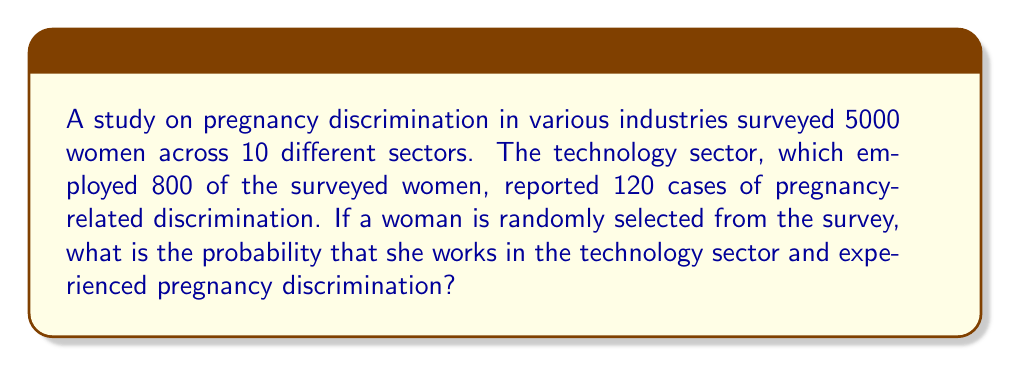Can you answer this question? Let's approach this step-by-step:

1) First, we need to calculate two probabilities:
   a) The probability of working in the technology sector
   b) The probability of experiencing pregnancy discrimination within the technology sector

2) Probability of working in the technology sector:
   $$P(\text{Tech}) = \frac{\text{Women in tech}}{\text{Total women}} = \frac{800}{5000} = 0.16$$

3) Probability of experiencing discrimination within the technology sector:
   $$P(\text{Discrimination} | \text{Tech}) = \frac{\text{Discrimination cases in tech}}{\text{Women in tech}} = \frac{120}{800} = 0.15$$

4) Now, we need to find the probability of both events occurring together. This is the intersection of these two events:
   $$P(\text{Tech and Discrimination}) = P(\text{Tech}) \times P(\text{Discrimination} | \text{Tech})$$

5) Substituting the values:
   $$P(\text{Tech and Discrimination}) = 0.16 \times 0.15 = 0.024$$

6) Convert to a percentage:
   $$0.024 \times 100\% = 2.4\%$$

Thus, the probability that a randomly selected woman from the survey works in the technology sector and experienced pregnancy discrimination is 2.4%.
Answer: 2.4% 